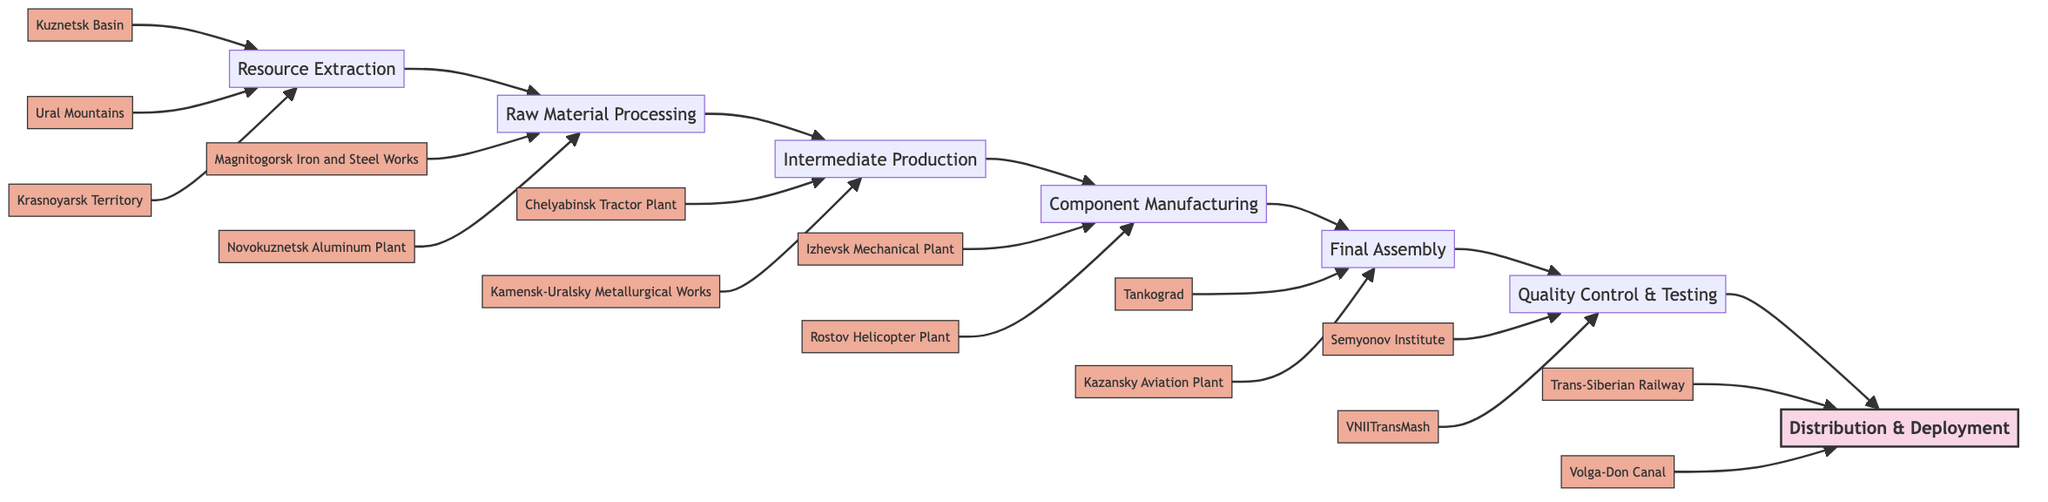What is the first stage of the process depicted in the diagram? The first stage is labeled as "Resource Extraction" in the flowchart, indicating it comes before any other stages.
Answer: Resource Extraction How many entities are associated with the "Component Manufacturing" stage? The "Component Manufacturing" stage directly connects to two entities, namely "Izhevsk Mechanical Plant" and "Rostov Helicopter Plant."
Answer: 2 What stage precedes "Final Assembly"? To determine this, we can trace the flowchart, and we see that "Component Manufacturing" directly connects to "Final Assembly," making it the stage before.
Answer: Component Manufacturing What is the last stage of the military industrialization process shown in the flowchart? The last stage is labeled as "Distribution & Deployment," appearing at the end of the flowchart.
Answer: Distribution & Deployment Which raw material is extracted from the Kuznetsk Basin? Referring to the "Resource Extraction" stage, it specifically lists "Kuznetsk Basin" as the source of coal.
Answer: Coal How many total stages are depicted in the flowchart? By counting each stage from "Resource Extraction" through "Distribution & Deployment," we find there are seven distinct stages altogether.
Answer: 7 What is the main purpose of the "Quality Control & Testing" stage? This stage is described as involving inspection, testing, and validation, emphasizing its role in ensuring reliability before deployment.
Answer: Reliability Which plant is associated with the creation of tanks? According to the diagram's "Final Assembly" stage, "Tankograd" is specified as the plant responsible for assembling tanks.
Answer: Tankograd What two entities are involved in raw material processing? In the "Raw Material Processing" stage, the diagram identifies two entities: "Magnitogorsk Iron and Steel Works" and "Novokuznetsk Aluminum Plant."
Answer: Magnitogorsk Iron and Steel Works, Novokuznetsk Aluminum Plant 